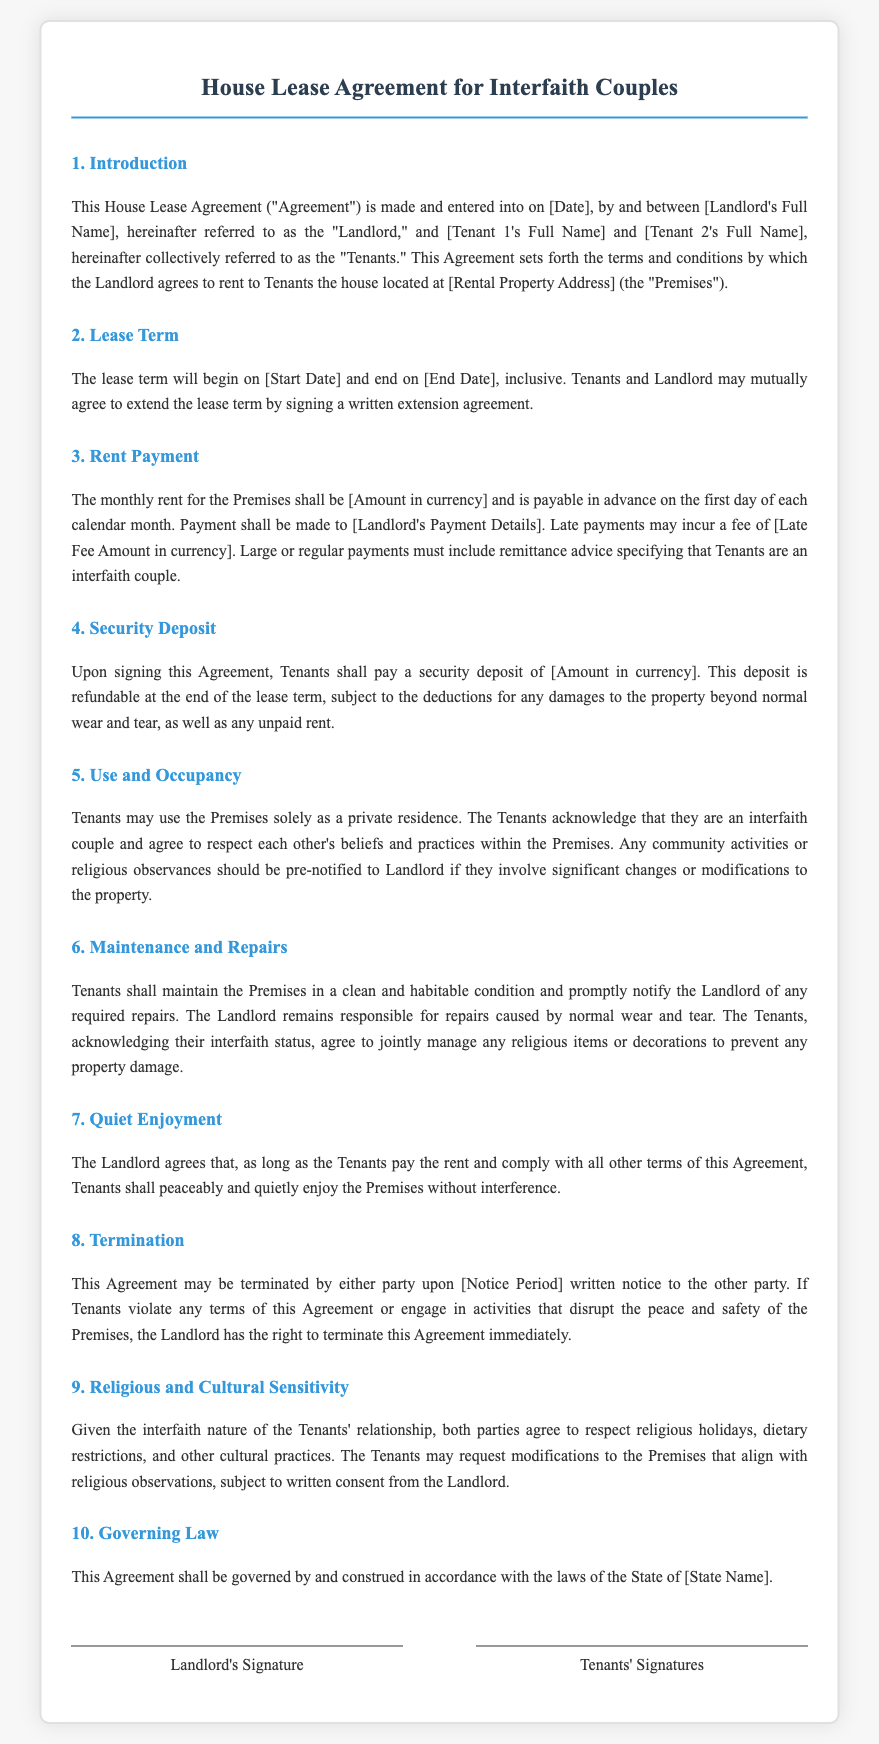What is the title of the document? The title of the document can be found at the top of the agreement, specifying its purpose and focus.
Answer: House Lease Agreement for Interfaith Couples What is the monthly rent amount? The monthly rent for the Premises is outlined in the rent payment section and should be specified directly in the agreement.
Answer: [Amount in currency] What is the security deposit amount? The security deposit amount can be found in the Security Deposit section, which specifies what Tenants must pay upon signing.
Answer: [Amount in currency] What is the lease termination notice period? The notice period for terminating the lease is specified in the Termination section and indicates how much notice must be given.
Answer: [Notice Period] What is required for modifications to the Premises related to religious observations? The document mentions that Tenants can request changes to align with religious observations, subject to a certain condition outlined in the Religious and Cultural Sensitivity section.
Answer: Written consent from the Landlord What are the Tenants' obligations regarding the maintenance of the Premises? The maintenance responsibilities of the Tenants are specified in the Maintenance and Repairs section, indicating what they must do to keep the property in good condition.
Answer: Maintain the Premises in a clean and habitable condition How does the Landlord ensure the Tenants' quiet enjoyment of the Premises? The commitment made by the Landlord regarding the Tenants' peaceful enjoyment can be found in the Quiet Enjoyment section of the agreement.
Answer: Without interference What must be included with large payments? This stipulation is listed in the Rent Payment section and indicates what additional information is needed with specific types of payment.
Answer: Remittance advice specifying that Tenants are an interfaith couple 